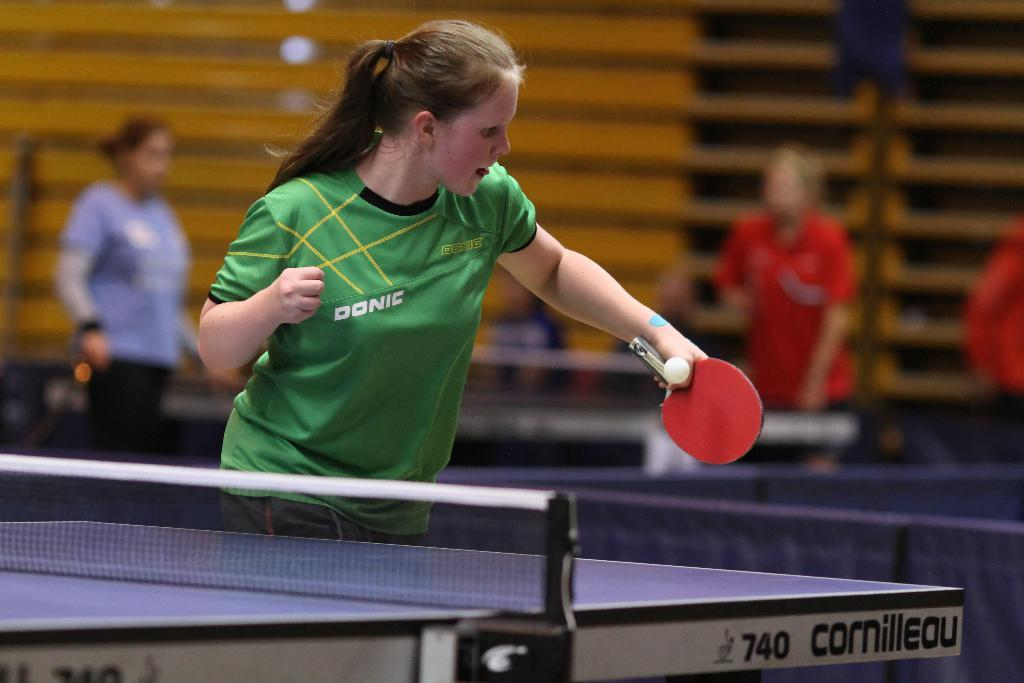What activity is the woman in the image engaged in? The woman in the image is playing table tennis. Are there any other people involved in the activity? No, there is only one woman playing table tennis. Can you describe the background of the image? In the background of the image, there are two women standing beside the table tennis court. What type of ornament is hanging from the ceiling above the table tennis court? There is no ornament hanging from the ceiling above the table tennis court in the image. 